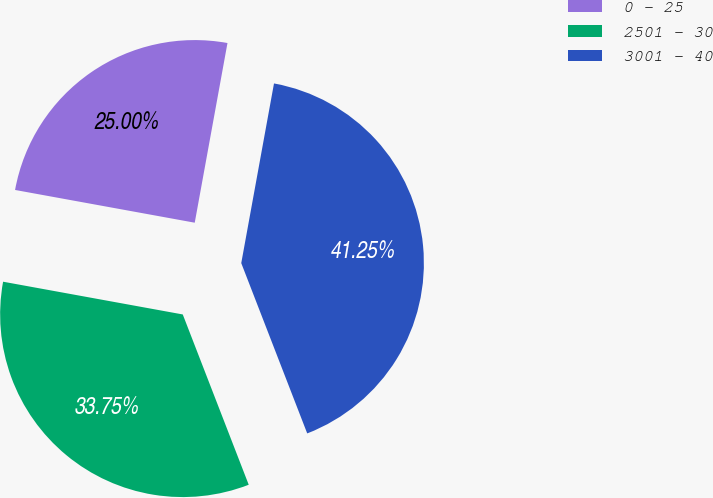Convert chart to OTSL. <chart><loc_0><loc_0><loc_500><loc_500><pie_chart><fcel>0 - 25<fcel>2501 - 30<fcel>3001 - 40<nl><fcel>25.0%<fcel>33.75%<fcel>41.25%<nl></chart> 